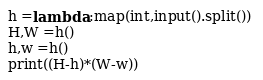<code> <loc_0><loc_0><loc_500><loc_500><_Python_>h =lambda :map(int,input().split()) 
H,W =h()
h,w =h()
print((H-h)*(W-w))</code> 